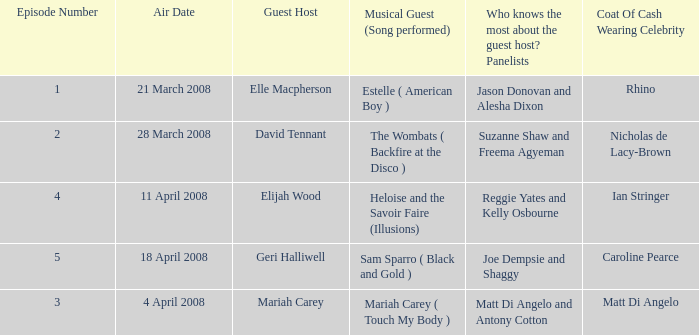Name the total number of episodes for coat of cash wearing celebrity is matt di angelo 1.0. 